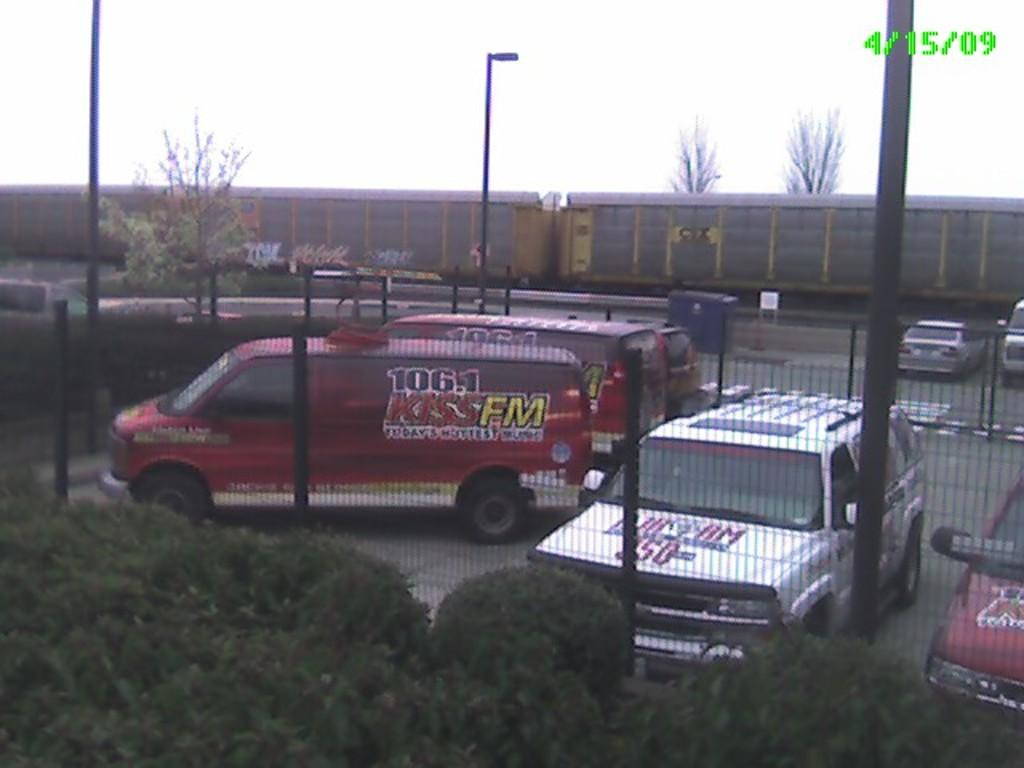What types of objects can be seen in the image? There are vehicles, trees, plants, a road, fencing, containers, and poles in the image. What can be seen in the background of the image? The sky is visible in the image. What type of vegetation is present in the image? There are trees and plants in the image. What might be used to separate or enclose areas in the image? The fencing in the image can be used to separate or enclose areas. What type of soda is being advertised on the containers in the image? There is no soda or advertisement present on the containers in the image; they are simply containers. Who is the owner of the vehicles in the image? There is no information about the ownership of the vehicles in the image. Can you find any clover growing in the image? There is no clover present in the image. 